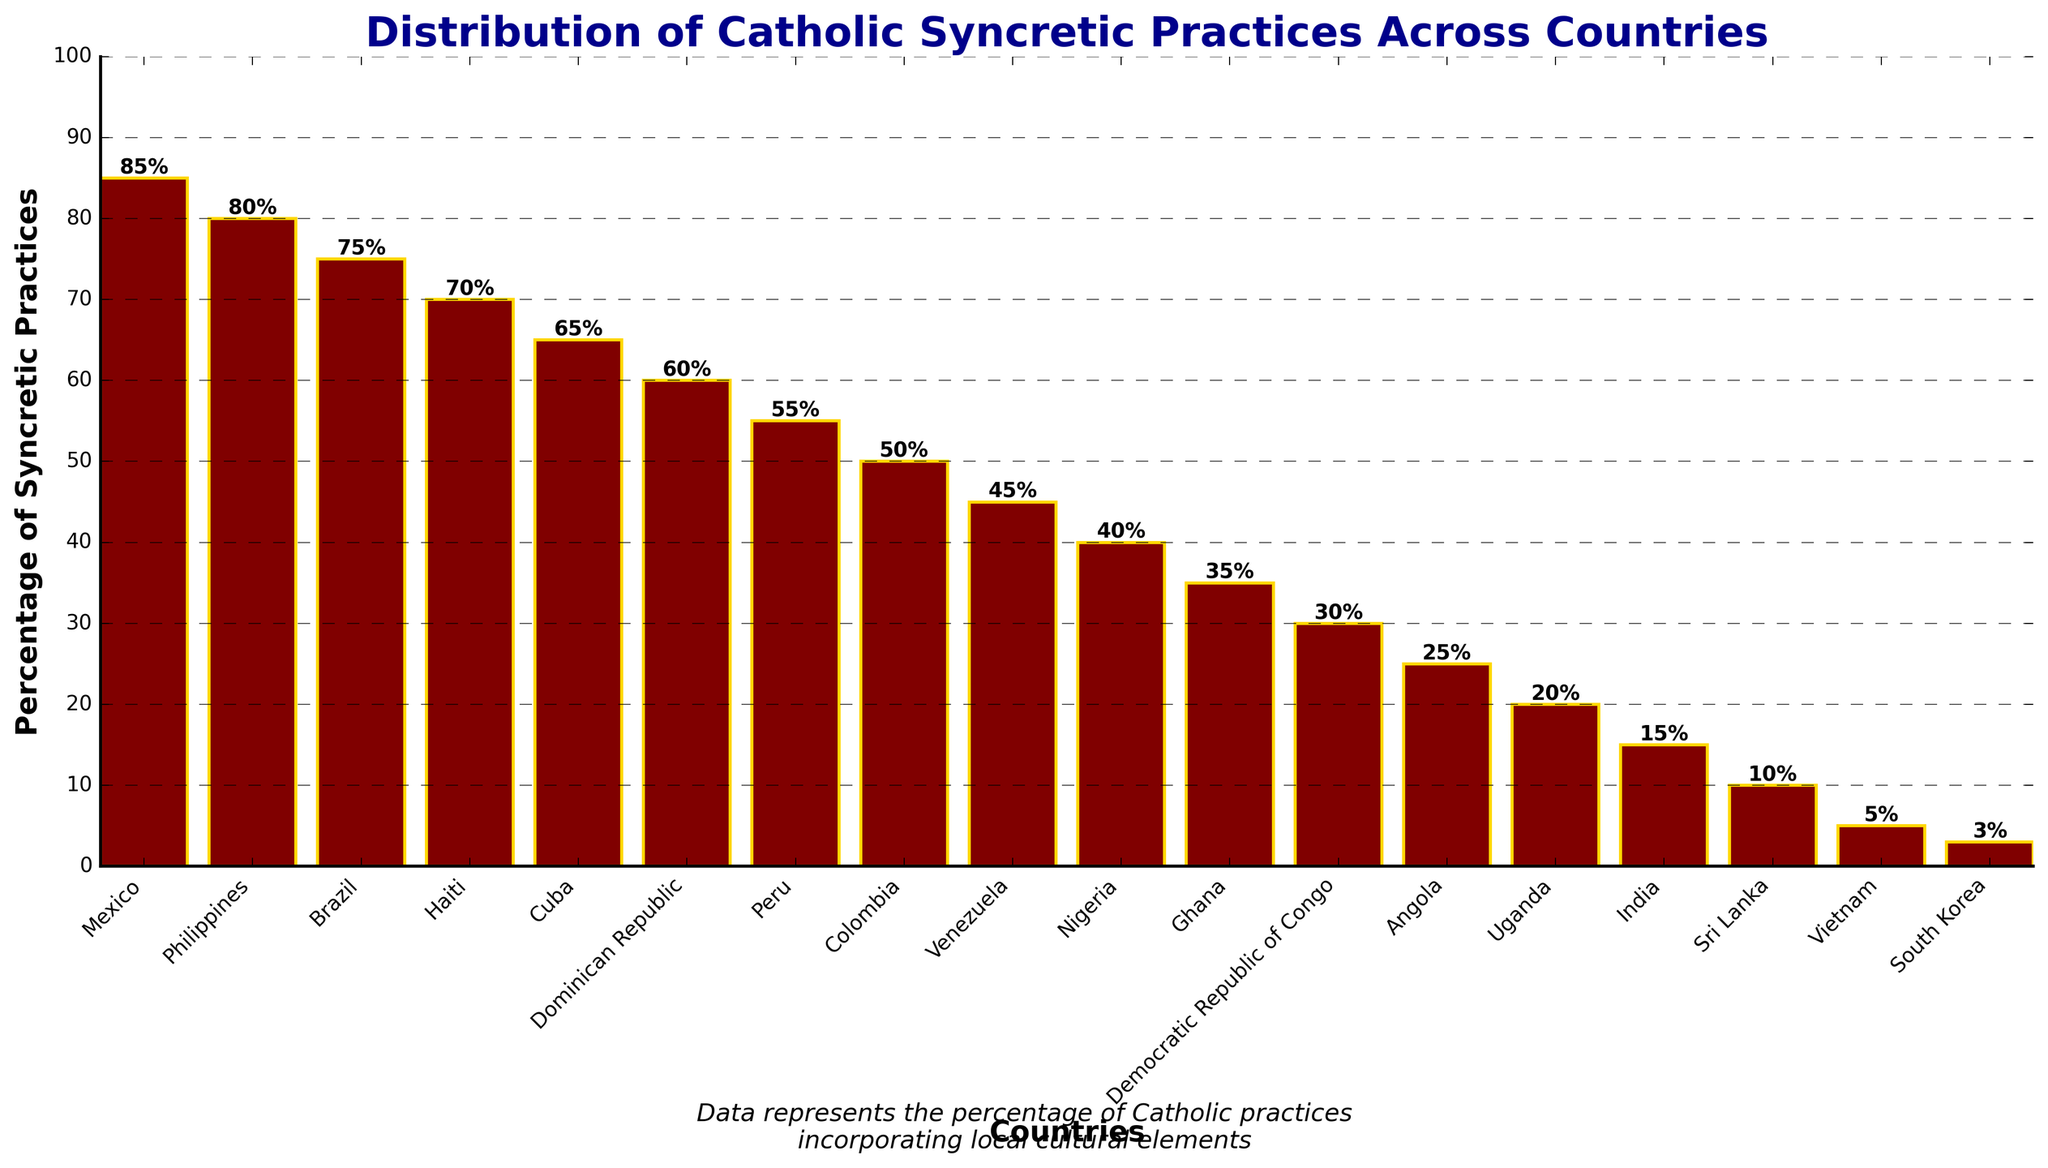Which country has the highest percentage of Catholic syncretic practices? The bar representing Mexico has the highest height, indicating that Mexico has the highest percentage.
Answer: Mexico Which two countries have the smallest percentage difference in syncretic practices? The bars for South Korea and Vietnam are very close in height, showing a small difference.
Answer: South Korea and Vietnam How many countries have a syncretic practice percentage of 50% or higher? Count the bars with heights at or above the mid-point of the vertical axis (50%). Those countries are Mexico, Philippines, Brazil, Haiti, Cuba, Dominican Republic, Peru, and Colombia (8 countries).
Answer: 8 What is the combined percentage of syncretic practices for Mexico and Vietnam? Add the percentages for Mexico and Vietnam (85% + 5%).
Answer: 90% Which country has a percentage that is half of the percentage of syncretic practices in Mexico? Divide Mexico's percentage by 2 (85% / 2 = 42.5%). The closest value is Nigeria with 40%.
Answer: Nigeria Which countries have more than 60% but less than 80% of syncretic practices? Check the countries with heights corresponding to percentages between 60% and 80%. Those countries are Brazil (75%), Haiti (70%), and Cuba (65%).
Answer: Brazil, Haiti, and Cuba Are there more countries with percentages below 50% or above 50%? Count the bars below and above the 50% line. Above 50%: 8 countries (Mexico, Philippines, Brazil, Haiti, Cuba, Dominican Republic, Peru, Colombia). Below 50%: 10 countries (Venezuela, Nigeria, Ghana, Democratic Republic of Congo, Angola, Uganda, India, Sri Lanka, Vietnam, South Korea).
Answer: More countries below 50% What is the percentage range (difference between the highest and lowest) of syncretic practices? Subtract the lowest percentage from the highest percentage (85% - 3%).
Answer: 82% How does the percentage of syncretic practices in the Philippines compare to that in Uganda? Philippines (80%) is significantly higher than Uganda (20%).
Answer: The Philippines is significantly higher Which continent has the highest representation in the top five countries with the highest syncretic practice percentages? Identify the top five countries (Mexico, Philippines, Brazil, Haiti, Cuba). Two are from Latin America and one from Asia.
Answer: Latin America 